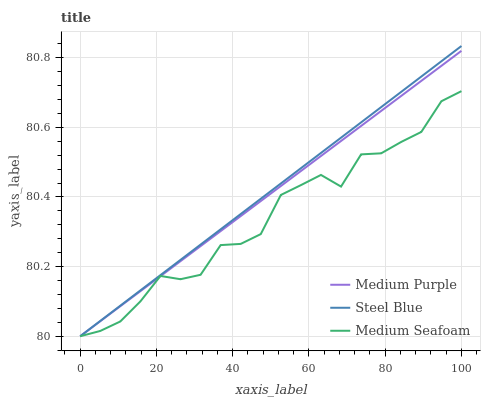Does Medium Seafoam have the minimum area under the curve?
Answer yes or no. Yes. Does Steel Blue have the maximum area under the curve?
Answer yes or no. Yes. Does Steel Blue have the minimum area under the curve?
Answer yes or no. No. Does Medium Seafoam have the maximum area under the curve?
Answer yes or no. No. Is Steel Blue the smoothest?
Answer yes or no. Yes. Is Medium Seafoam the roughest?
Answer yes or no. Yes. Is Medium Seafoam the smoothest?
Answer yes or no. No. Is Steel Blue the roughest?
Answer yes or no. No. Does Medium Purple have the lowest value?
Answer yes or no. Yes. Does Steel Blue have the highest value?
Answer yes or no. Yes. Does Medium Seafoam have the highest value?
Answer yes or no. No. Does Medium Purple intersect Steel Blue?
Answer yes or no. Yes. Is Medium Purple less than Steel Blue?
Answer yes or no. No. Is Medium Purple greater than Steel Blue?
Answer yes or no. No. 